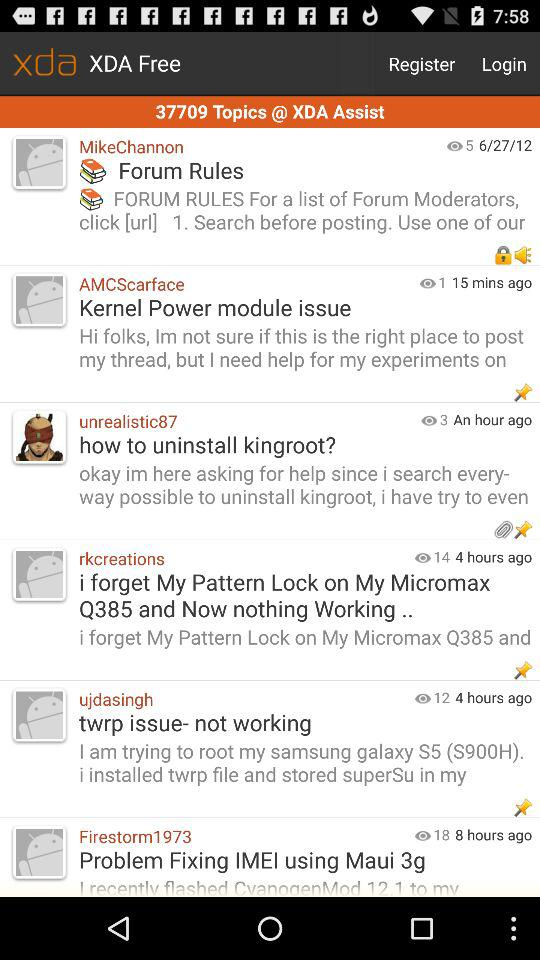What is the application name? The application name is "xda". 